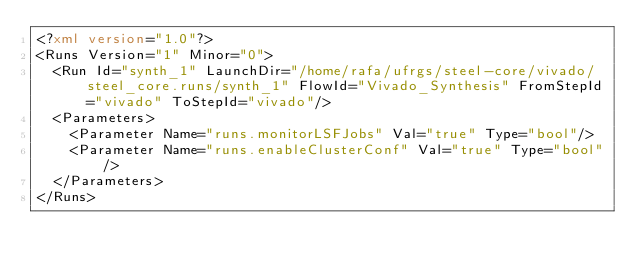Convert code to text. <code><loc_0><loc_0><loc_500><loc_500><_XML_><?xml version="1.0"?>
<Runs Version="1" Minor="0">
	<Run Id="synth_1" LaunchDir="/home/rafa/ufrgs/steel-core/vivado/steel_core.runs/synth_1" FlowId="Vivado_Synthesis" FromStepId="vivado" ToStepId="vivado"/>
	<Parameters>
		<Parameter Name="runs.monitorLSFJobs" Val="true" Type="bool"/>
		<Parameter Name="runs.enableClusterConf" Val="true" Type="bool"/>
	</Parameters>
</Runs>

</code> 